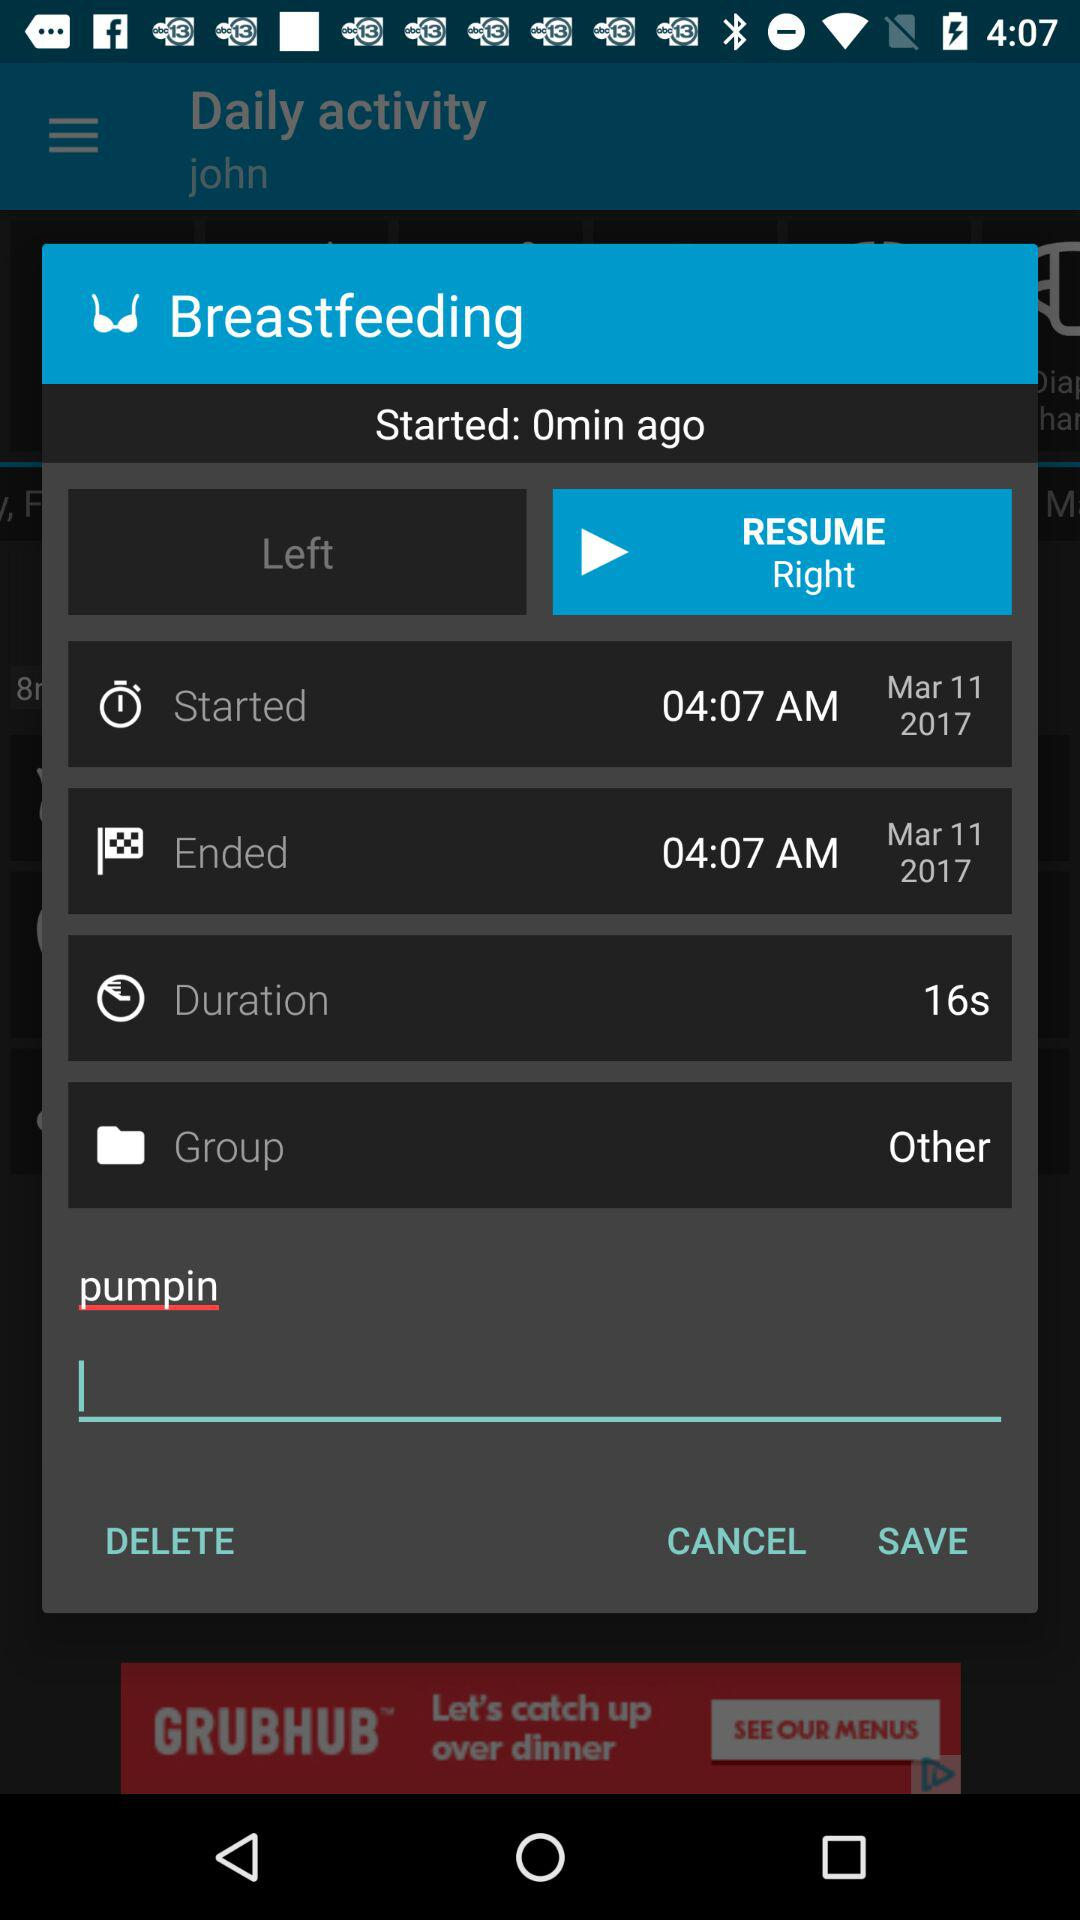Which tab is selected right now?
When the provided information is insufficient, respond with <no answer>. <no answer> 